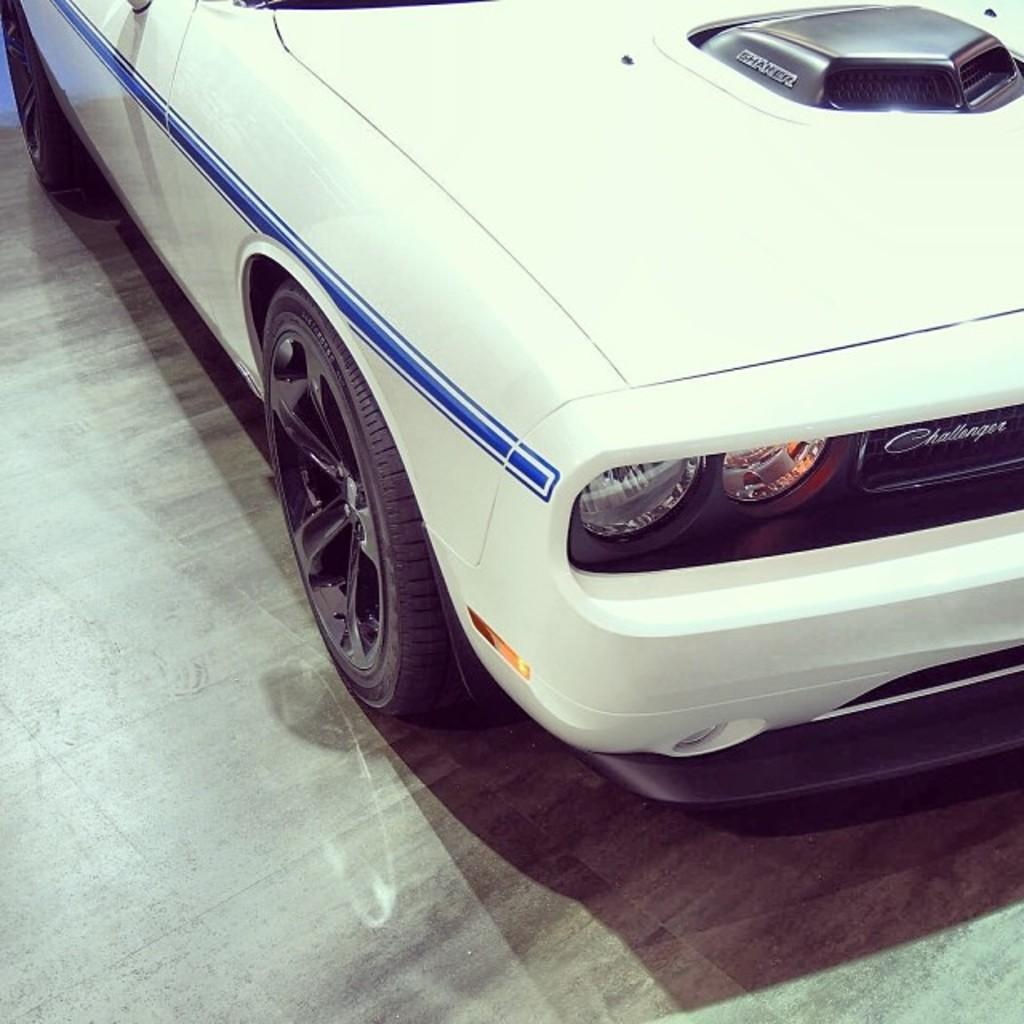What is the main subject of the image? The main subject of the image is a car. What color is the car? The car is white in color. What are some of the car's features? The car has wheels, headlights, a bonnet, and a bumper. Are there any other objects attached to the car? Yes, there are other objects attached to the car. What is visible on the floor in the image? The floor is visible in the image. Can you tell me how many boats are parked next to the car in the image? There are no boats present in the image; it only features a car. What type of garden is visible in the image? There is no garden present in the image. 